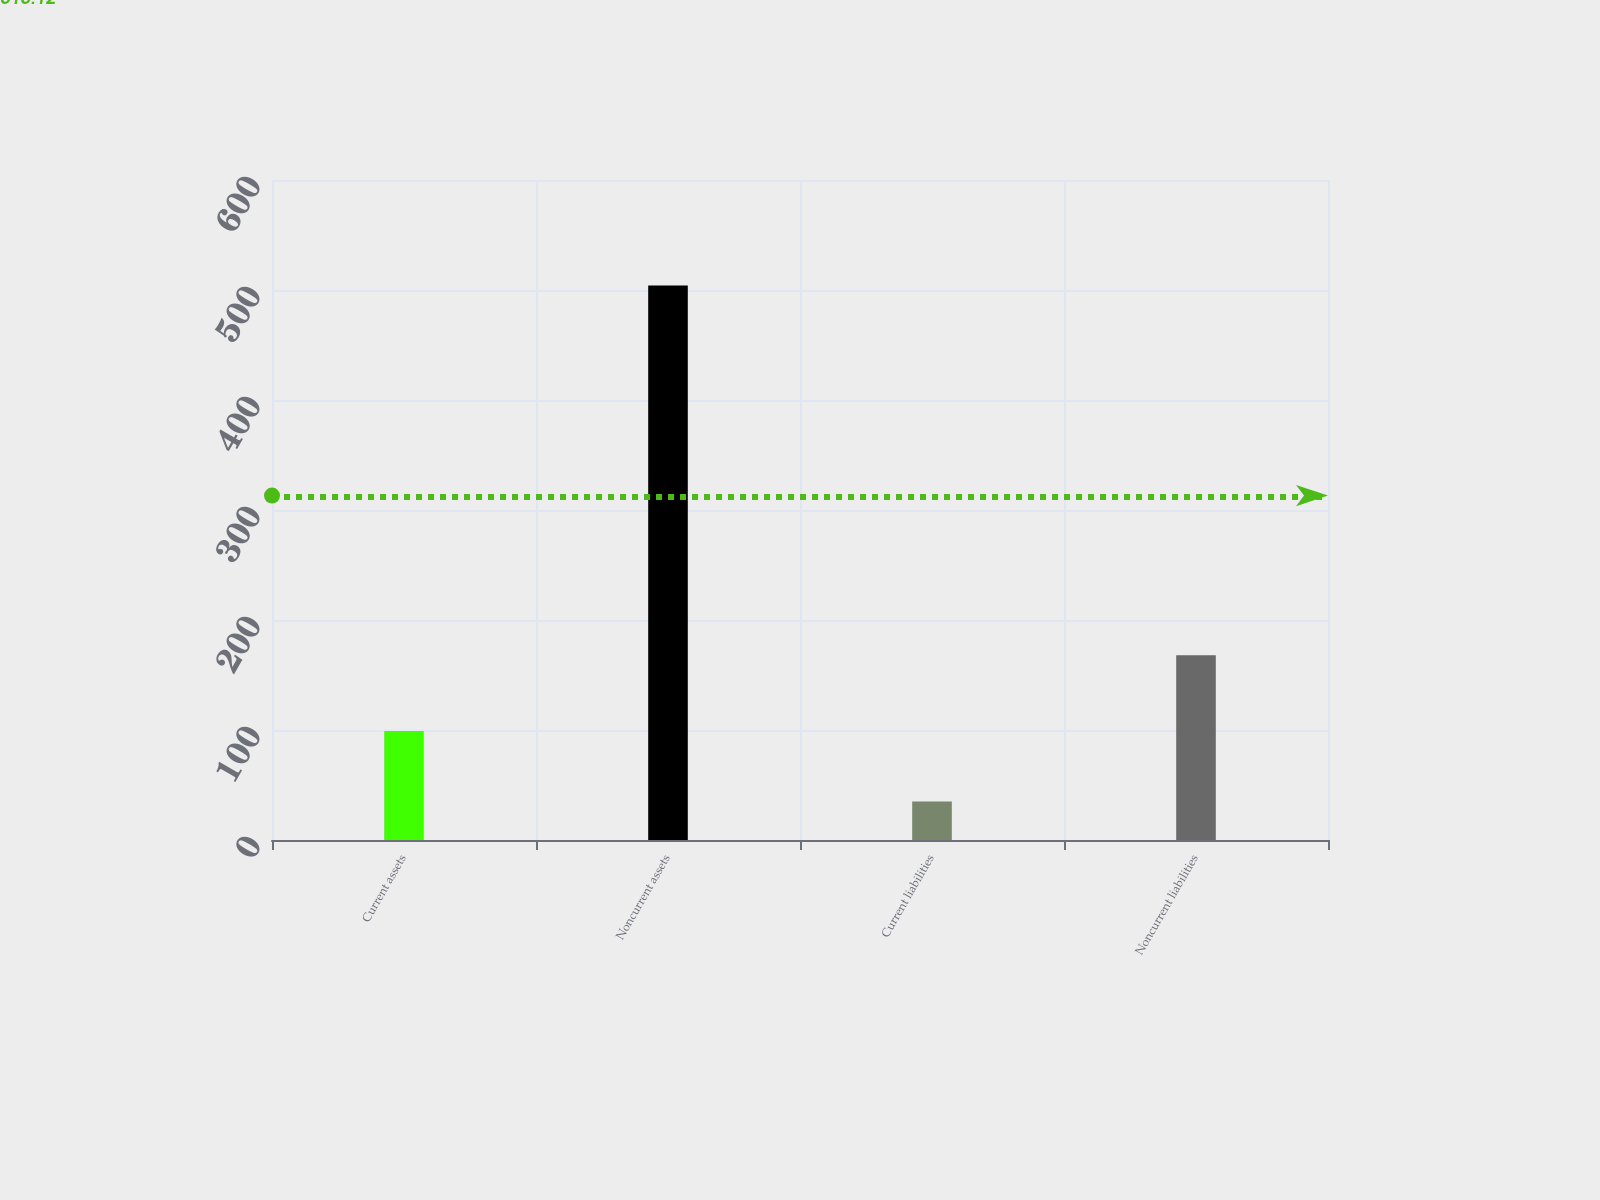Convert chart. <chart><loc_0><loc_0><loc_500><loc_500><bar_chart><fcel>Current assets<fcel>Noncurrent assets<fcel>Current liabilities<fcel>Noncurrent liabilities<nl><fcel>99<fcel>504<fcel>35<fcel>168<nl></chart> 